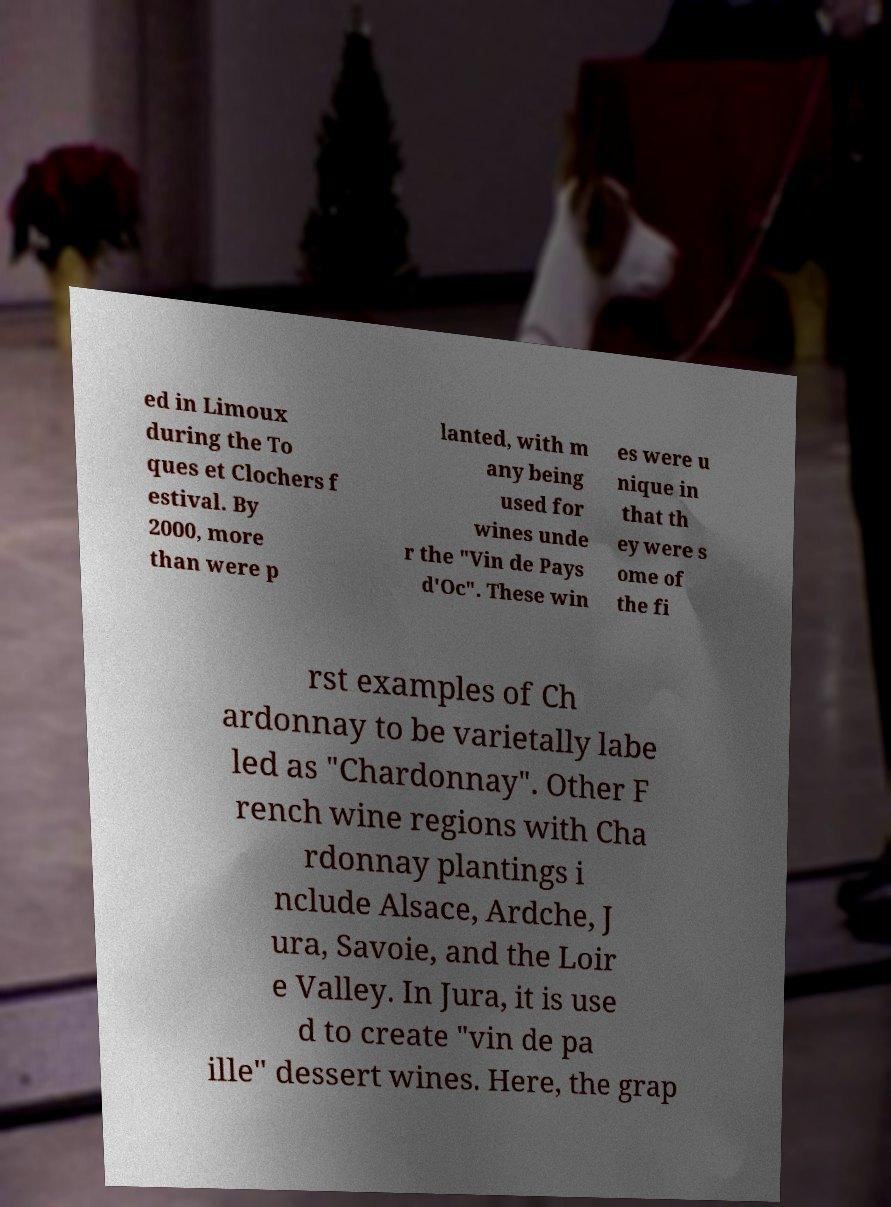Can you read and provide the text displayed in the image?This photo seems to have some interesting text. Can you extract and type it out for me? ed in Limoux during the To ques et Clochers f estival. By 2000, more than were p lanted, with m any being used for wines unde r the "Vin de Pays d'Oc". These win es were u nique in that th ey were s ome of the fi rst examples of Ch ardonnay to be varietally labe led as "Chardonnay". Other F rench wine regions with Cha rdonnay plantings i nclude Alsace, Ardche, J ura, Savoie, and the Loir e Valley. In Jura, it is use d to create "vin de pa ille" dessert wines. Here, the grap 